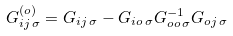Convert formula to latex. <formula><loc_0><loc_0><loc_500><loc_500>G _ { i j \, \sigma } ^ { ( o ) } = G _ { i j \, \sigma } - G _ { i o \, \sigma } G _ { o o \, \sigma } ^ { - 1 } G _ { o j \, \sigma }</formula> 